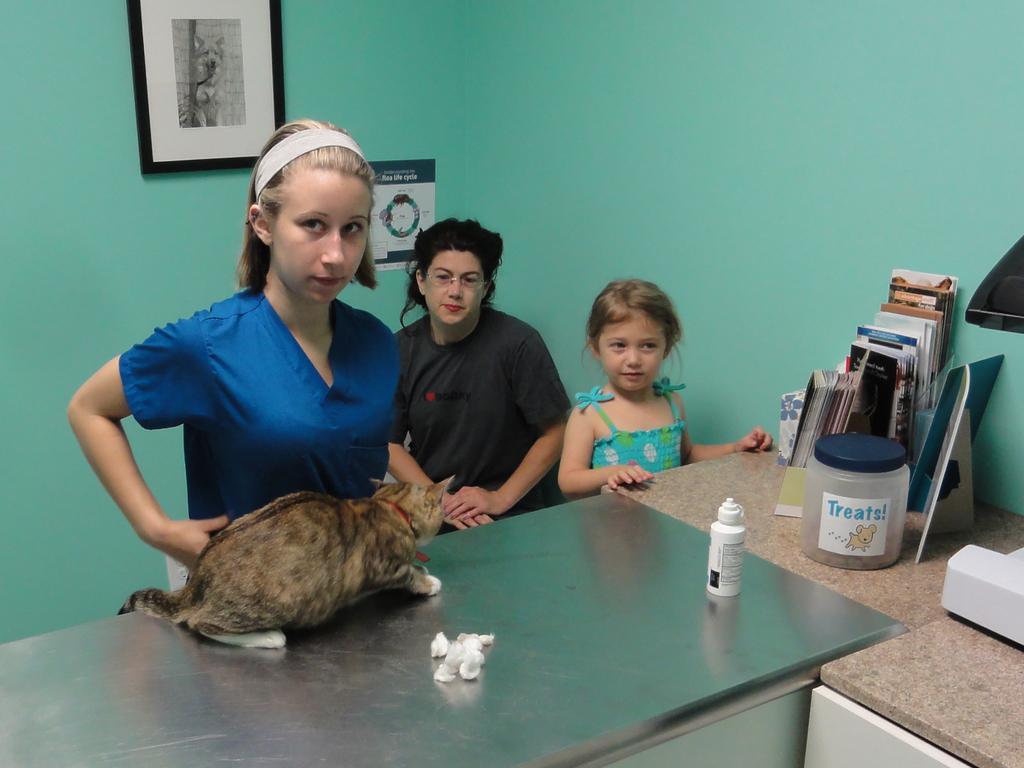In one or two sentences, can you explain what this image depicts? In this image I can see a cat, bottle, container, books and frames on a table. 3 people are present. There are photo frames on green wall. 